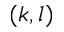<formula> <loc_0><loc_0><loc_500><loc_500>( k , l )</formula> 